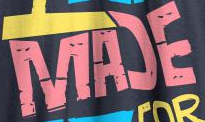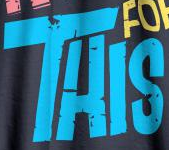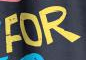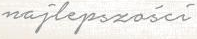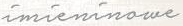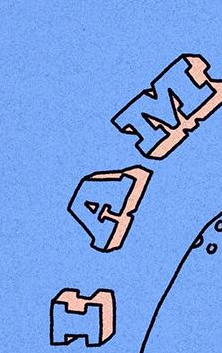Read the text from these images in sequence, separated by a semicolon. MAƆE; THIS; FOR; najlepszości; imieninowe; IAM 